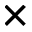Convert formula to latex. <formula><loc_0><loc_0><loc_500><loc_500>\times</formula> 